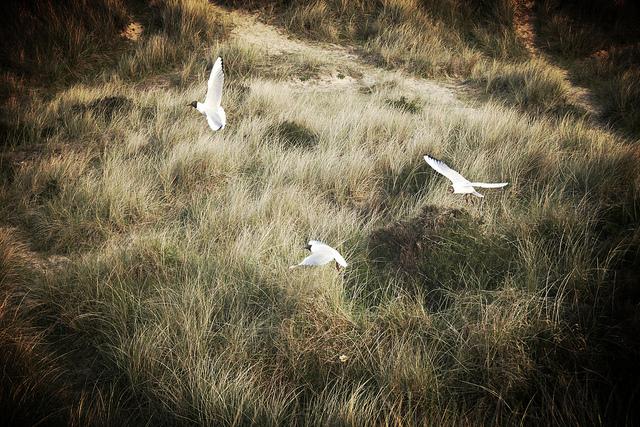What are the color of the birds?
Write a very short answer. White. Is the grass tall?
Keep it brief. Yes. Are the birds flying?
Quick response, please. Yes. 